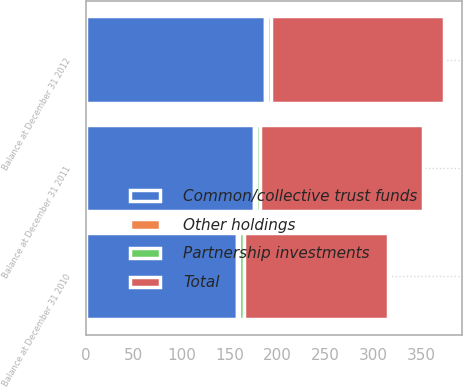<chart> <loc_0><loc_0><loc_500><loc_500><stacked_bar_chart><ecel><fcel>Balance at December 31 2010<fcel>Balance at December 31 2011<fcel>Balance at December 31 2012<nl><fcel>Common/collective trust funds<fcel>158<fcel>176<fcel>187<nl><fcel>Partnership investments<fcel>5<fcel>4<fcel>5<nl><fcel>Total<fcel>151<fcel>170<fcel>180<nl><fcel>Other holdings<fcel>2<fcel>2<fcel>2<nl></chart> 